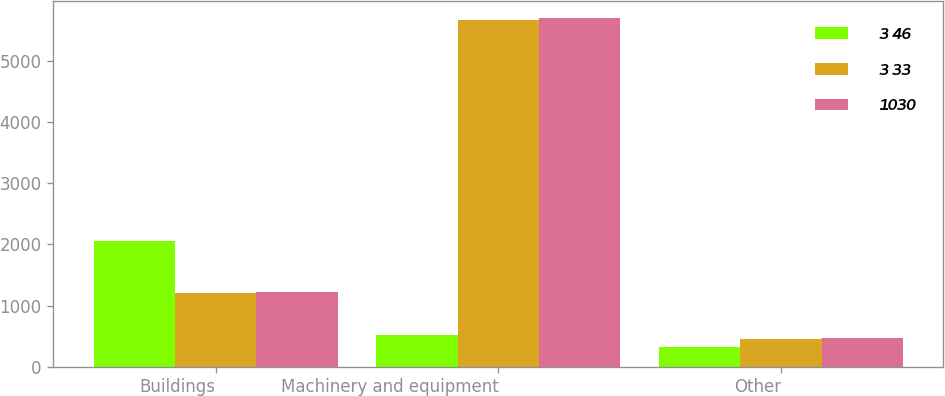Convert chart. <chart><loc_0><loc_0><loc_500><loc_500><stacked_bar_chart><ecel><fcel>Buildings<fcel>Machinery and equipment<fcel>Other<nl><fcel>3 46<fcel>2050<fcel>525<fcel>320<nl><fcel>3 33<fcel>1201<fcel>5674<fcel>452<nl><fcel>1030<fcel>1224<fcel>5707<fcel>468<nl></chart> 